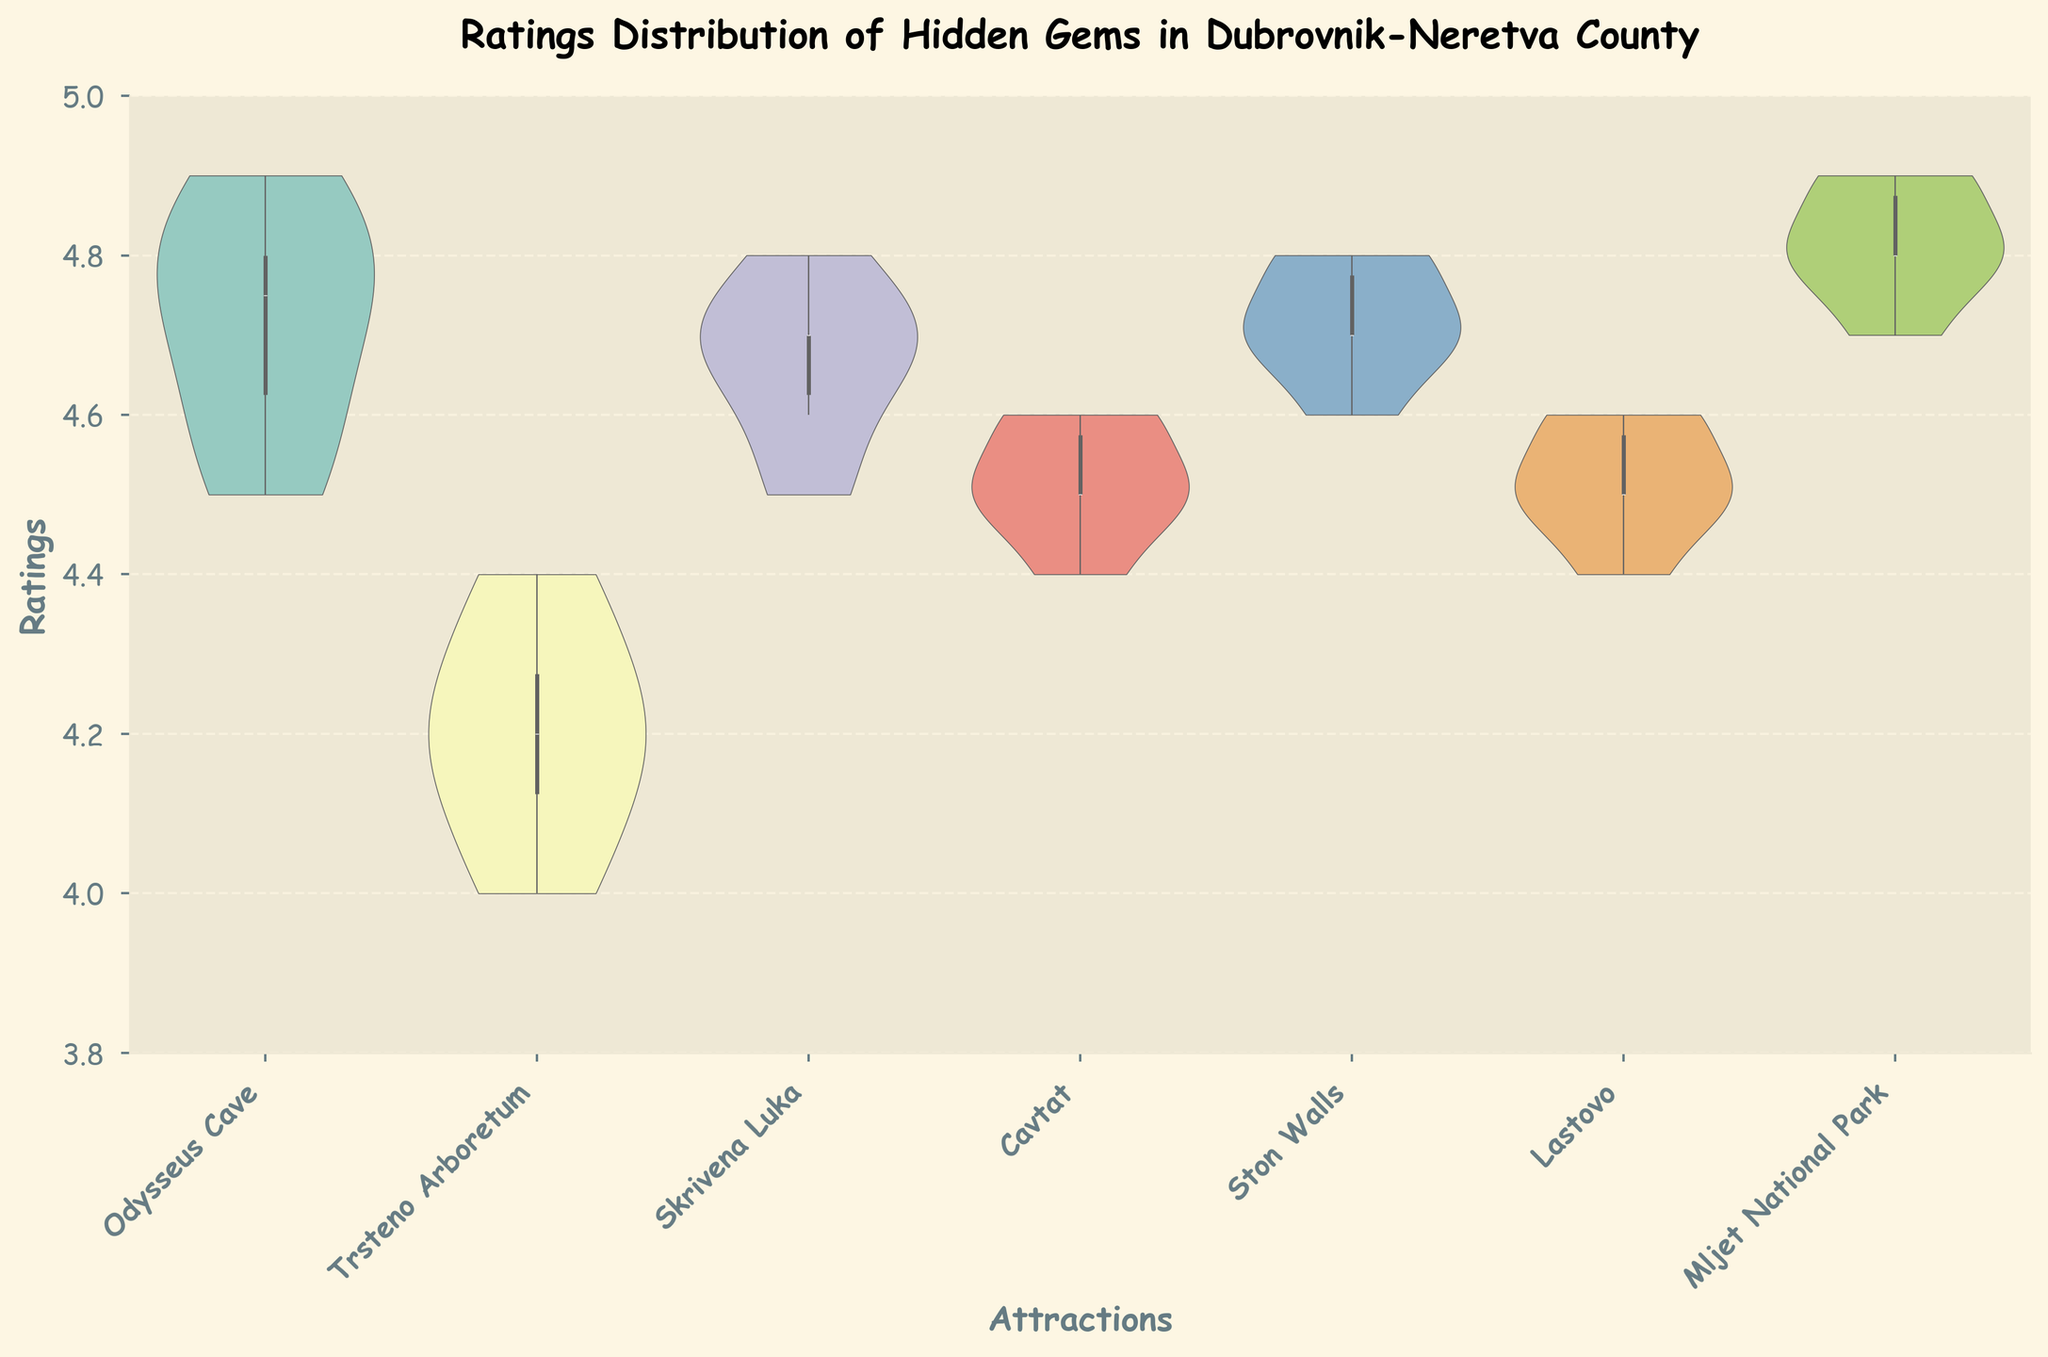How many hidden gem attractions are included in the chart? The X-axis of the chart lists the different hidden gem attractions. By counting the unique names along the X-axis, we can determine the number of attractions.
Answer: 7 What is the range of ratings observed for Odysseus Cave? The range is determined by finding the difference between the maximum and minimum ratings of Odysseus Cave visible in the violin plot. The maximum rating is 4.9 and the minimum rating is 4.5.
Answer: 0.4 Which attraction has the highest median rating? The median rating is represented by the white dot in the center of the violin plot. By comparing these dots across the attractions, we can determine that Mljet National Park has the highest median rating.
Answer: Mljet National Park Between Ston Walls and Skrivena Luka, which attraction has a wider spread of ratings? To find the attraction with the wider spread, we compare the length of the violin plots for Ston Walls and Skrivena Luka. Ston Walls has a longer spread than Skrivena Luka.
Answer: Ston Walls What is the similarity in the median ratings of Cavtat and Lastovo? The median ratings are visually indicated by the white dots in their respective violin plots. Both Cavtat and Lastovo have their median ratings close to each other around the value of 4.5.
Answer: Both are around 4.5 How do the interquartile ranges of the ratings for Trsteno Arboretum and Skrivena Luka compare? The interquartile range is the length of the box in the box plot overlay. By comparing the boxes for Trsteno Arboretum and Skrivena Luka, it is evident that Skrivena Luka has a slightly larger interquartile range compared to Trsteno Arboretum.
Answer: Skrivena Luka has a slightly larger IQR Are there any outliers visible in the ratings data for any of the attractions? Outliers in the box plot overlay would be shown as individual points outside the whiskers. By inspecting the plots, there are no visible outliers.
Answer: No What can you infer about the symmetry of the rating distributions of Mljet National Park and Lastovo? The symmetry of distributions can be assessed by looking at the shape of the violin plots. Mljet National Park has a fairly symmetrical distribution, while Lastovo shows minor asymmetry with a slight bias towards the higher ratings.
Answer: Mljet is symmetrical; Lastovo is slightly right-skewed 